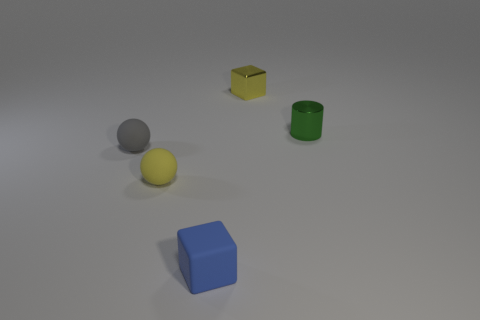Are there fewer small blue cylinders than small green cylinders? Yes, there are. In the image, there is one small green cylinder, while no small blue cylinders are present at all. 